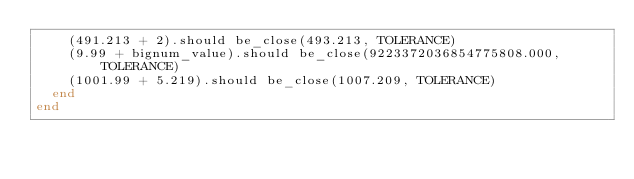Convert code to text. <code><loc_0><loc_0><loc_500><loc_500><_Ruby_>    (491.213 + 2).should be_close(493.213, TOLERANCE)
    (9.99 + bignum_value).should be_close(9223372036854775808.000, TOLERANCE)
    (1001.99 + 5.219).should be_close(1007.209, TOLERANCE)
  end
end
</code> 